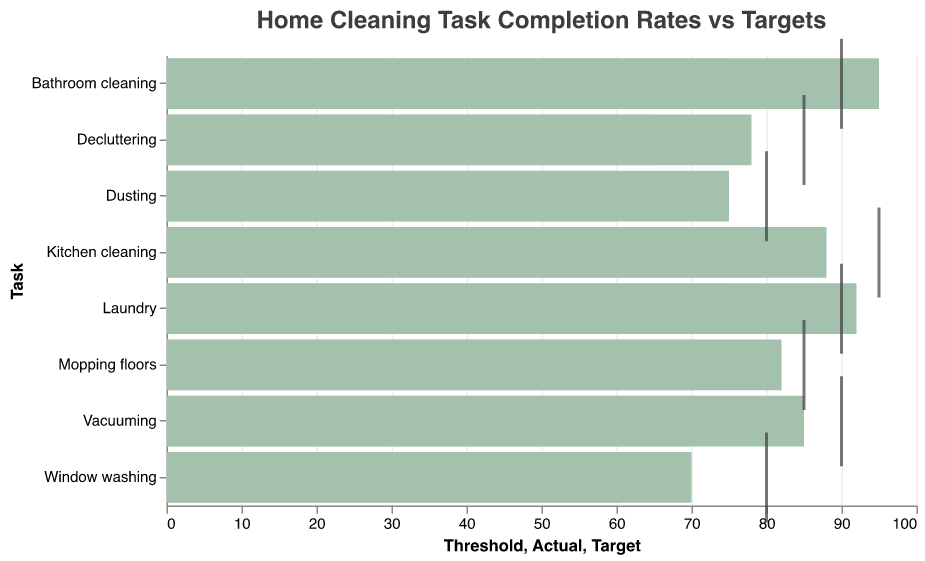What is the title of the figure? The title is provided at the top of the chart, visually distinct due to its larger font size and bold styling.
Answer: Home Cleaning Task Completion Rates vs Targets What color represents the actual cleaning task completion rates in the figure? By observing the chart, we notice the actual completion rates are represented by green-colored bars.
Answer: Green Which cleaning task has an actual completion rate that meets or exceeds its target? The chart shows tick marks at the target values, with bars representing actual rates. The Bathroom cleaning has an actual rate of 95 and a target of 90, and Laundry has an actual rate of 92 and a target of 90, both meeting or exceeding their targets.
Answer: Bathroom cleaning and Laundry What is the difference between the actual and target rates for Kitchen cleaning? The actual rate for Kitchen cleaning is shown as 88, and the target rate is marked at 95. Subtracting the actual rate from the target rate gives us 95 - 88 = 7.
Answer: 7 For which task is the actual completion rate furthest from its target? By comparing the visual distances between the actual and target rates, we notice that Window washing shows a significant gap with an actual rate of 70 and a target of 80.
Answer: Window washing Which tasks have an actual completion rate that also surpasses their respective threshold? The bars that extend past the threshold marks signify these tasks. By looking, we see Vacuuming, Dusting, Bathroom cleaning, Kitchen cleaning, Laundry, Mopping floors, and Decluttering exceed their thresholds. This can be counted logically by seeing bar lengths.
Answer: Seven tasks What is the average target completion rate across all tasks? Sum up the target rates (90 + 80 + 90 + 95 + 90 + 80 + 85 + 85) = 695, then divide by the number of tasks (8), so 695 / 8 = 86.875
Answer: 86.875 How many tasks have an actual completion rate below their target rate? By examining the distance to target marks on the chart, we can count Vacuuming, Dusting, Kitchen cleaning, Window washing, Mopping floors, and Decluttering as below target.
Answer: Six tasks Which task has the smallest margin between its actual completion rate and its threshold? Margin can be calculated by subtracting threshold from the actual rate. Dusting has the smallest margin at 75 - 60 = 15.
Answer: Dusting What is the total actual completion rate for all tasks combined? Add up all the actual rates given (85 + 75 + 95 + 88 + 92 + 70 + 82 + 78) = 665.
Answer: 665 